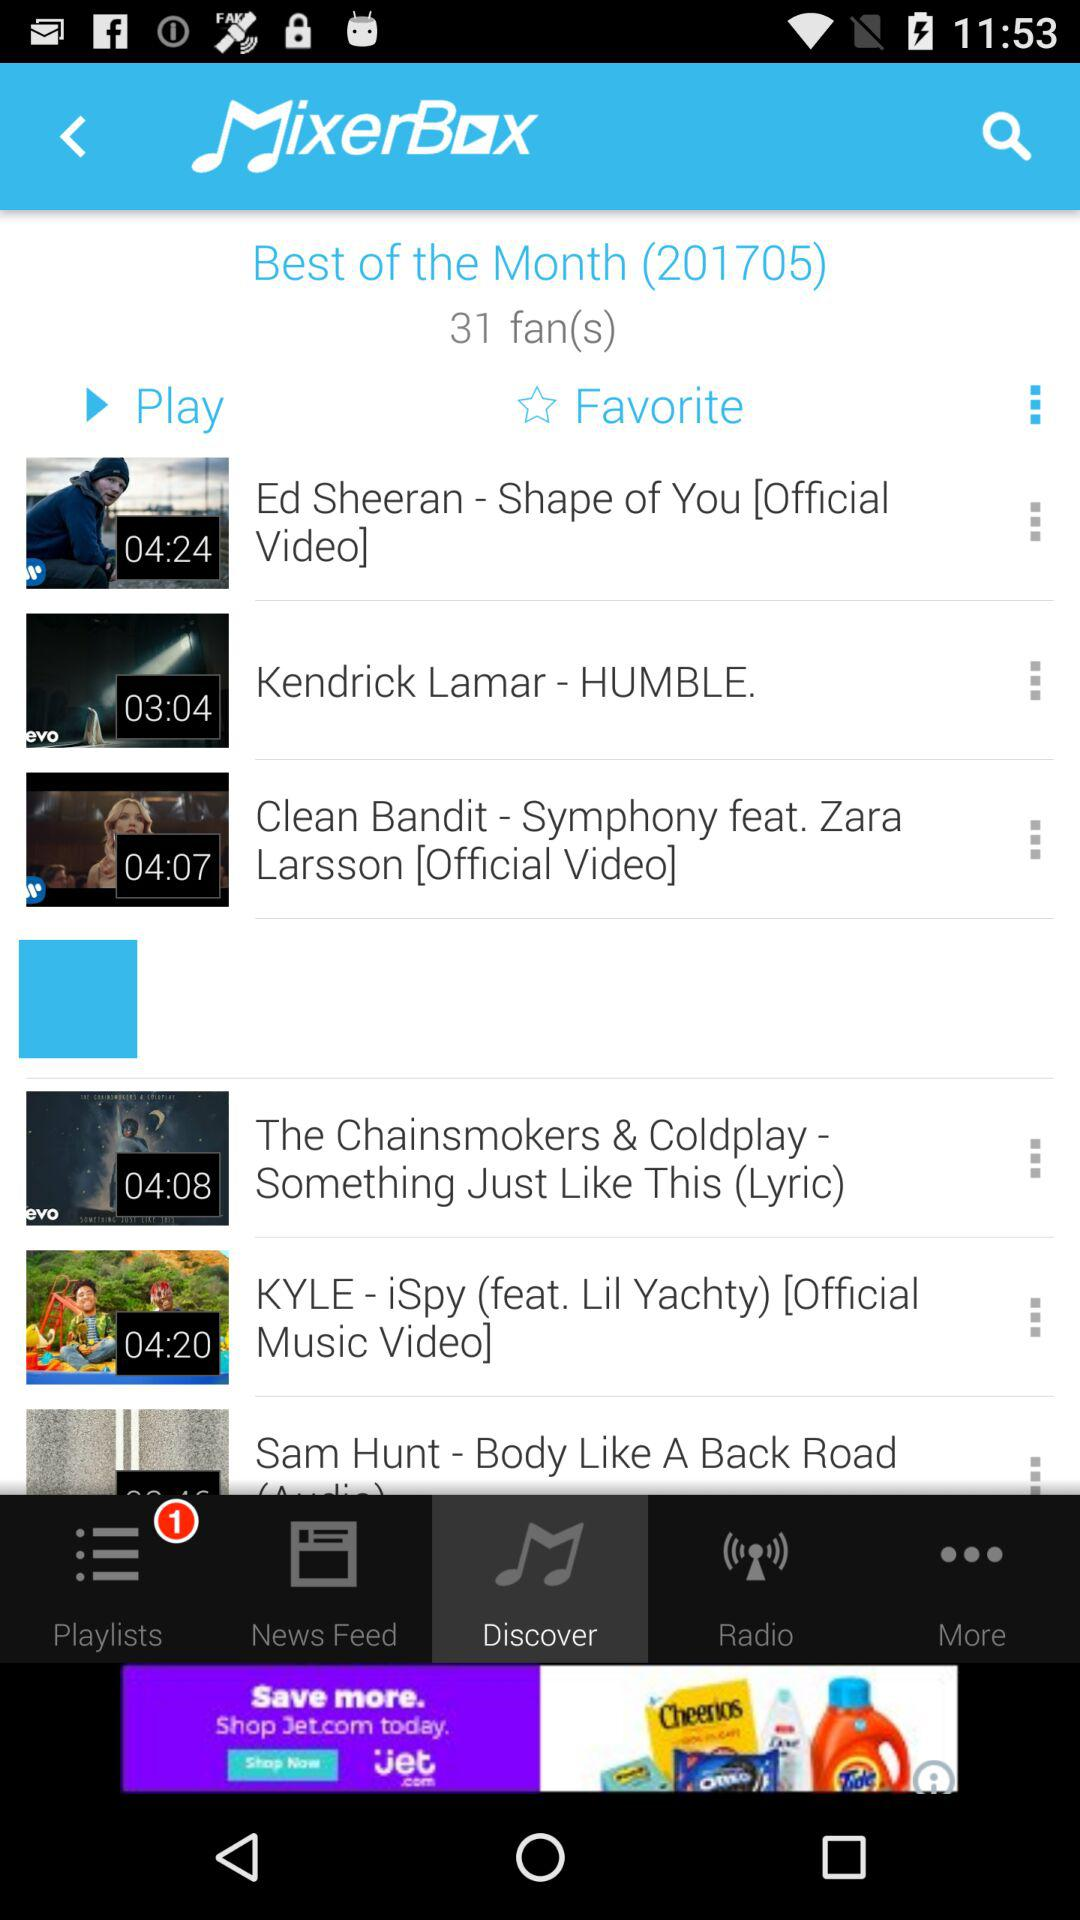What is the number of fans? The number of fans is 31. 